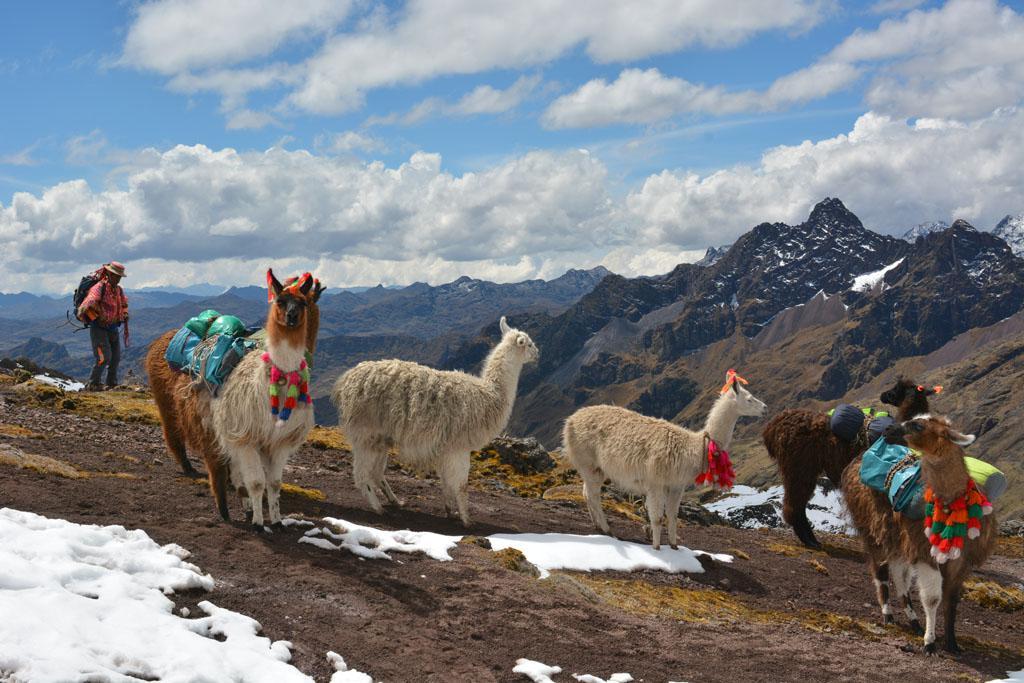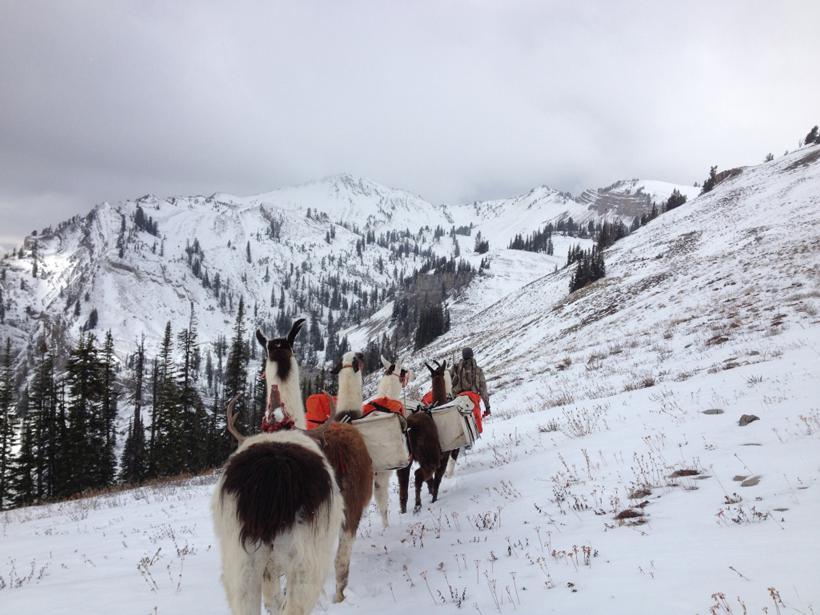The first image is the image on the left, the second image is the image on the right. For the images shown, is this caption "The landscape shows a cloudy blue sky on the left image." true? Answer yes or no. Yes. 